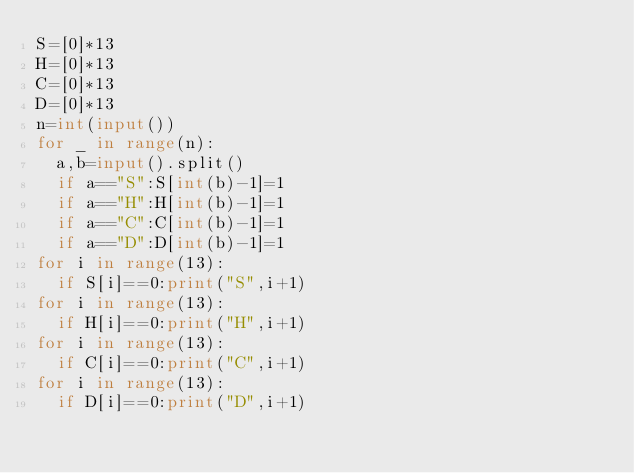Convert code to text. <code><loc_0><loc_0><loc_500><loc_500><_Python_>S=[0]*13
H=[0]*13
C=[0]*13
D=[0]*13
n=int(input())
for _ in range(n):
  a,b=input().split()
  if a=="S":S[int(b)-1]=1
  if a=="H":H[int(b)-1]=1
  if a=="C":C[int(b)-1]=1
  if a=="D":D[int(b)-1]=1
for i in range(13):
  if S[i]==0:print("S",i+1)
for i in range(13):
  if H[i]==0:print("H",i+1)
for i in range(13):
  if C[i]==0:print("C",i+1)
for i in range(13):
  if D[i]==0:print("D",i+1)
</code> 